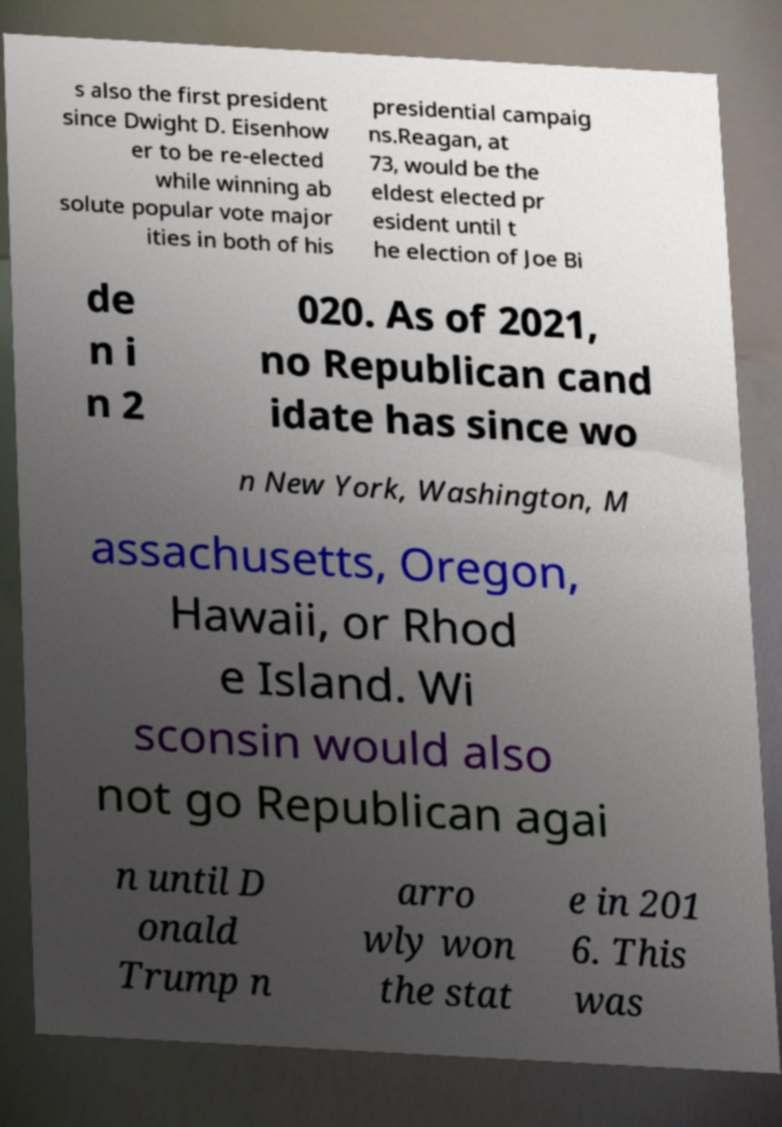There's text embedded in this image that I need extracted. Can you transcribe it verbatim? s also the first president since Dwight D. Eisenhow er to be re-elected while winning ab solute popular vote major ities in both of his presidential campaig ns.Reagan, at 73, would be the eldest elected pr esident until t he election of Joe Bi de n i n 2 020. As of 2021, no Republican cand idate has since wo n New York, Washington, M assachusetts, Oregon, Hawaii, or Rhod e Island. Wi sconsin would also not go Republican agai n until D onald Trump n arro wly won the stat e in 201 6. This was 